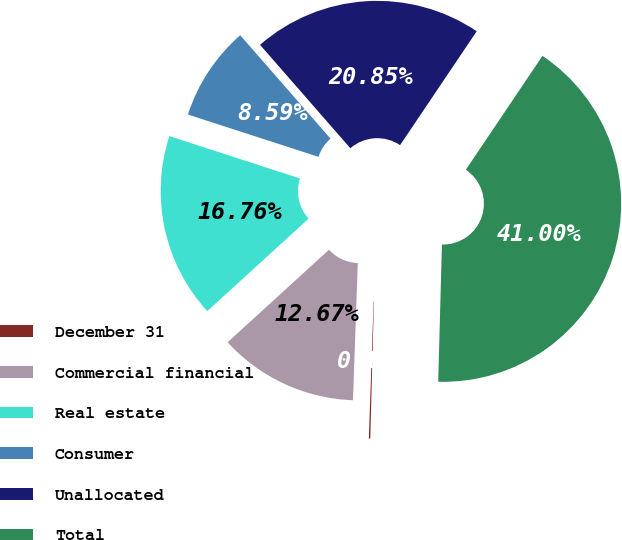<chart> <loc_0><loc_0><loc_500><loc_500><pie_chart><fcel>December 31<fcel>Commercial financial<fcel>Real estate<fcel>Consumer<fcel>Unallocated<fcel>Total<nl><fcel>0.13%<fcel>12.67%<fcel>16.76%<fcel>8.59%<fcel>20.85%<fcel>41.0%<nl></chart> 